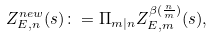<formula> <loc_0><loc_0><loc_500><loc_500>Z _ { E , n } ^ { n e w } ( s ) \colon = \Pi _ { m | n } Z _ { E , m } ^ { \beta ( \frac { n } { m } ) } ( s ) ,</formula> 